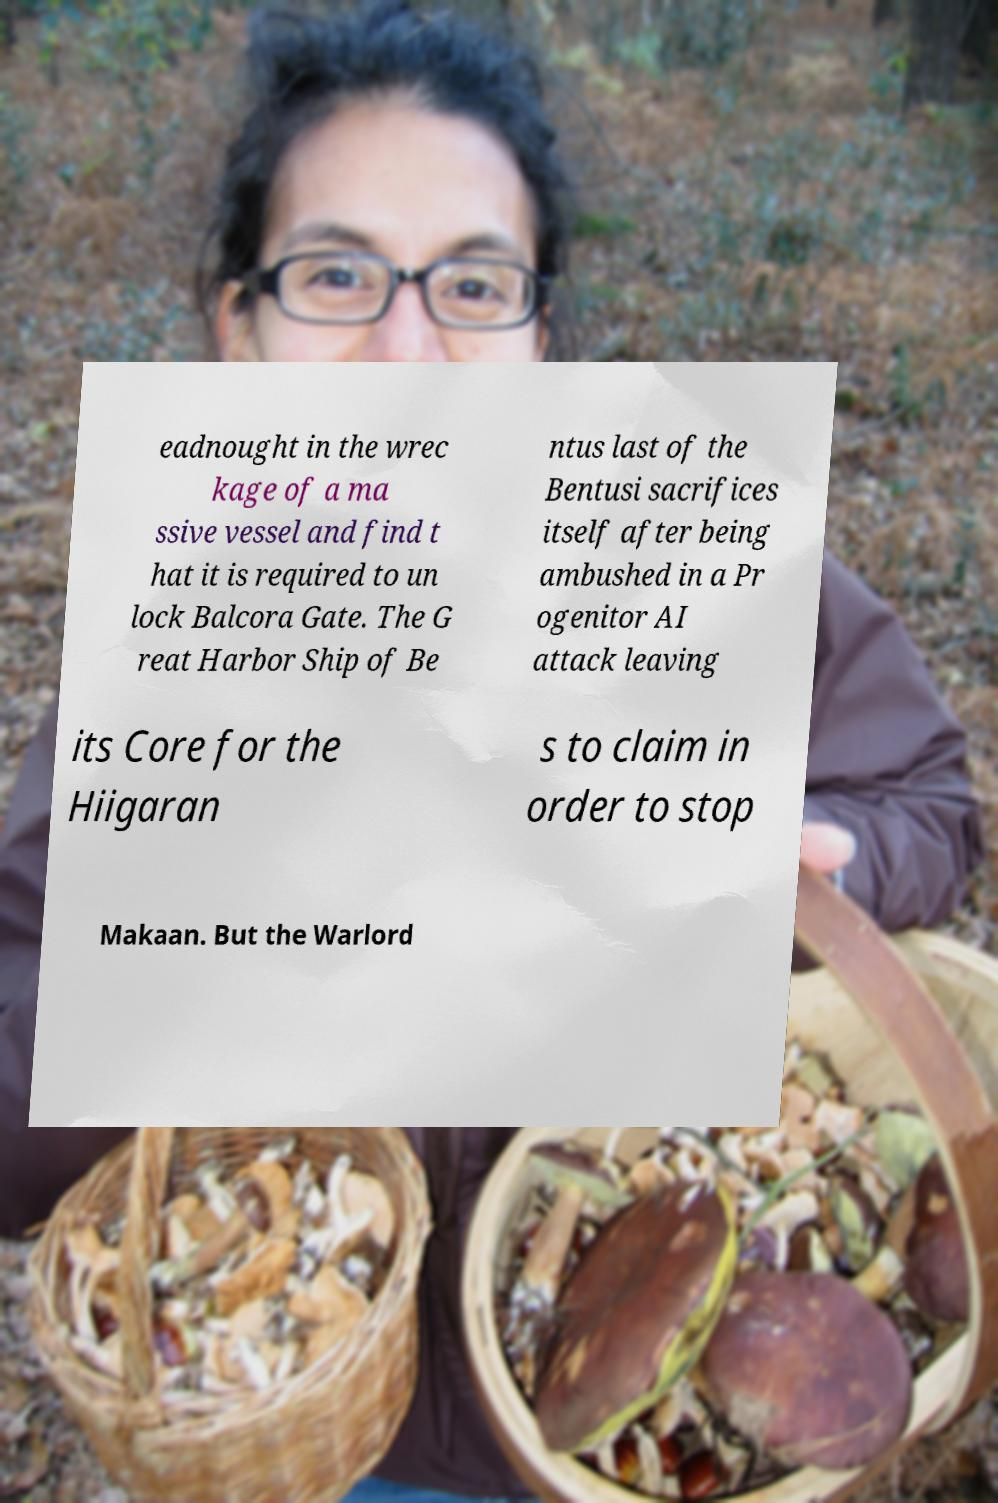For documentation purposes, I need the text within this image transcribed. Could you provide that? eadnought in the wrec kage of a ma ssive vessel and find t hat it is required to un lock Balcora Gate. The G reat Harbor Ship of Be ntus last of the Bentusi sacrifices itself after being ambushed in a Pr ogenitor AI attack leaving its Core for the Hiigaran s to claim in order to stop Makaan. But the Warlord 